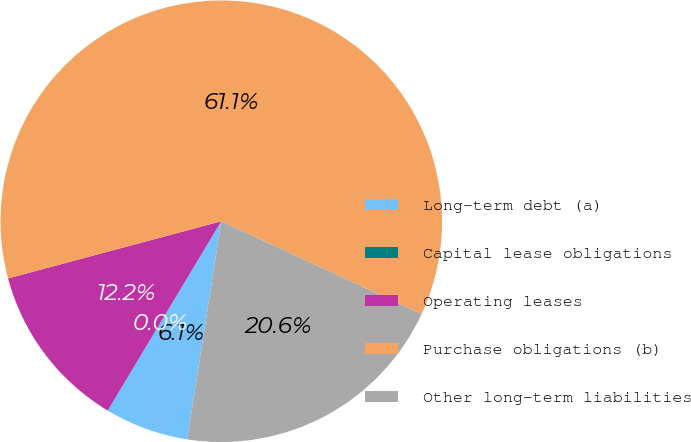<chart> <loc_0><loc_0><loc_500><loc_500><pie_chart><fcel>Long-term debt (a)<fcel>Capital lease obligations<fcel>Operating leases<fcel>Purchase obligations (b)<fcel>Other long-term liabilities<nl><fcel>6.12%<fcel>0.02%<fcel>12.23%<fcel>61.07%<fcel>20.56%<nl></chart> 